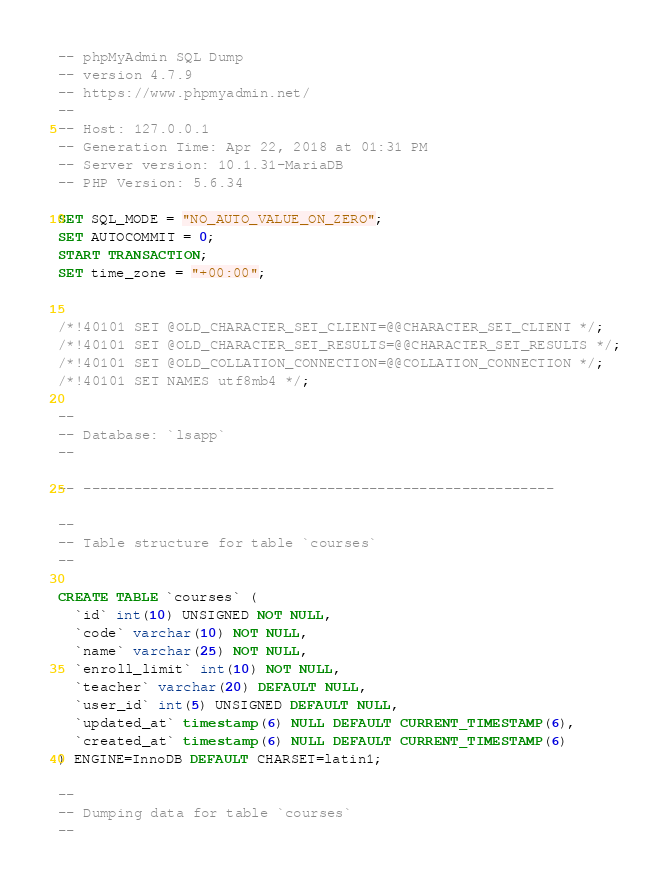Convert code to text. <code><loc_0><loc_0><loc_500><loc_500><_SQL_>-- phpMyAdmin SQL Dump
-- version 4.7.9
-- https://www.phpmyadmin.net/
--
-- Host: 127.0.0.1
-- Generation Time: Apr 22, 2018 at 01:31 PM
-- Server version: 10.1.31-MariaDB
-- PHP Version: 5.6.34

SET SQL_MODE = "NO_AUTO_VALUE_ON_ZERO";
SET AUTOCOMMIT = 0;
START TRANSACTION;
SET time_zone = "+00:00";


/*!40101 SET @OLD_CHARACTER_SET_CLIENT=@@CHARACTER_SET_CLIENT */;
/*!40101 SET @OLD_CHARACTER_SET_RESULTS=@@CHARACTER_SET_RESULTS */;
/*!40101 SET @OLD_COLLATION_CONNECTION=@@COLLATION_CONNECTION */;
/*!40101 SET NAMES utf8mb4 */;

--
-- Database: `lsapp`
--

-- --------------------------------------------------------

--
-- Table structure for table `courses`
--

CREATE TABLE `courses` (
  `id` int(10) UNSIGNED NOT NULL,
  `code` varchar(10) NOT NULL,
  `name` varchar(25) NOT NULL,
  `enroll_limit` int(10) NOT NULL,
  `teacher` varchar(20) DEFAULT NULL,
  `user_id` int(5) UNSIGNED DEFAULT NULL,
  `updated_at` timestamp(6) NULL DEFAULT CURRENT_TIMESTAMP(6),
  `created_at` timestamp(6) NULL DEFAULT CURRENT_TIMESTAMP(6)
) ENGINE=InnoDB DEFAULT CHARSET=latin1;

--
-- Dumping data for table `courses`
--
</code> 